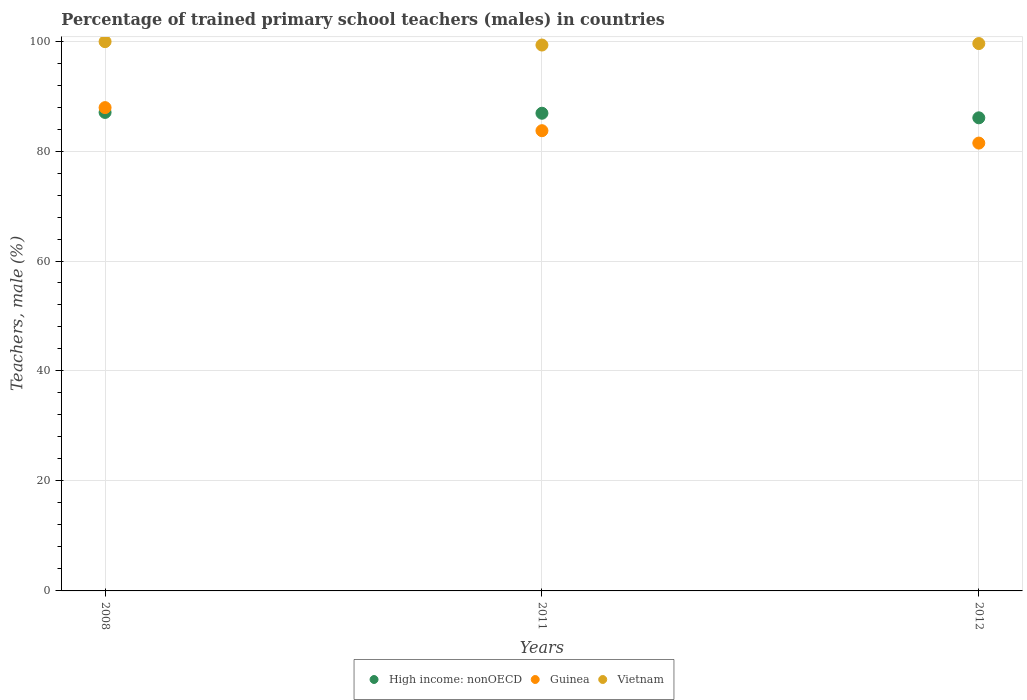What is the percentage of trained primary school teachers (males) in Vietnam in 2012?
Your answer should be very brief. 99.55. Across all years, what is the maximum percentage of trained primary school teachers (males) in Vietnam?
Provide a succinct answer. 99.89. Across all years, what is the minimum percentage of trained primary school teachers (males) in High income: nonOECD?
Make the answer very short. 86.04. In which year was the percentage of trained primary school teachers (males) in Vietnam maximum?
Your answer should be very brief. 2008. In which year was the percentage of trained primary school teachers (males) in Vietnam minimum?
Keep it short and to the point. 2011. What is the total percentage of trained primary school teachers (males) in Guinea in the graph?
Provide a succinct answer. 253.04. What is the difference between the percentage of trained primary school teachers (males) in High income: nonOECD in 2008 and that in 2012?
Keep it short and to the point. 0.98. What is the difference between the percentage of trained primary school teachers (males) in Vietnam in 2012 and the percentage of trained primary school teachers (males) in High income: nonOECD in 2008?
Your answer should be very brief. 12.53. What is the average percentage of trained primary school teachers (males) in High income: nonOECD per year?
Give a very brief answer. 86.64. In the year 2012, what is the difference between the percentage of trained primary school teachers (males) in Guinea and percentage of trained primary school teachers (males) in Vietnam?
Keep it short and to the point. -18.1. What is the ratio of the percentage of trained primary school teachers (males) in High income: nonOECD in 2008 to that in 2011?
Give a very brief answer. 1. Is the percentage of trained primary school teachers (males) in High income: nonOECD in 2008 less than that in 2011?
Give a very brief answer. No. What is the difference between the highest and the second highest percentage of trained primary school teachers (males) in Vietnam?
Your answer should be compact. 0.35. What is the difference between the highest and the lowest percentage of trained primary school teachers (males) in High income: nonOECD?
Provide a short and direct response. 0.98. Is the sum of the percentage of trained primary school teachers (males) in Vietnam in 2008 and 2012 greater than the maximum percentage of trained primary school teachers (males) in Guinea across all years?
Offer a terse response. Yes. Is the percentage of trained primary school teachers (males) in Vietnam strictly greater than the percentage of trained primary school teachers (males) in High income: nonOECD over the years?
Provide a succinct answer. Yes. Is the percentage of trained primary school teachers (males) in High income: nonOECD strictly less than the percentage of trained primary school teachers (males) in Vietnam over the years?
Your answer should be very brief. Yes. How many dotlines are there?
Make the answer very short. 3. How many years are there in the graph?
Provide a short and direct response. 3. Does the graph contain any zero values?
Offer a very short reply. No. How many legend labels are there?
Provide a short and direct response. 3. How are the legend labels stacked?
Make the answer very short. Horizontal. What is the title of the graph?
Give a very brief answer. Percentage of trained primary school teachers (males) in countries. Does "Cameroon" appear as one of the legend labels in the graph?
Your response must be concise. No. What is the label or title of the X-axis?
Make the answer very short. Years. What is the label or title of the Y-axis?
Your answer should be very brief. Teachers, male (%). What is the Teachers, male (%) in High income: nonOECD in 2008?
Offer a terse response. 87.02. What is the Teachers, male (%) of Guinea in 2008?
Your answer should be compact. 87.9. What is the Teachers, male (%) of Vietnam in 2008?
Make the answer very short. 99.89. What is the Teachers, male (%) in High income: nonOECD in 2011?
Make the answer very short. 86.87. What is the Teachers, male (%) in Guinea in 2011?
Your answer should be very brief. 83.7. What is the Teachers, male (%) of Vietnam in 2011?
Offer a very short reply. 99.28. What is the Teachers, male (%) of High income: nonOECD in 2012?
Give a very brief answer. 86.04. What is the Teachers, male (%) in Guinea in 2012?
Ensure brevity in your answer.  81.45. What is the Teachers, male (%) in Vietnam in 2012?
Your answer should be compact. 99.55. Across all years, what is the maximum Teachers, male (%) in High income: nonOECD?
Keep it short and to the point. 87.02. Across all years, what is the maximum Teachers, male (%) of Guinea?
Give a very brief answer. 87.9. Across all years, what is the maximum Teachers, male (%) of Vietnam?
Offer a very short reply. 99.89. Across all years, what is the minimum Teachers, male (%) in High income: nonOECD?
Keep it short and to the point. 86.04. Across all years, what is the minimum Teachers, male (%) of Guinea?
Ensure brevity in your answer.  81.45. Across all years, what is the minimum Teachers, male (%) in Vietnam?
Keep it short and to the point. 99.28. What is the total Teachers, male (%) in High income: nonOECD in the graph?
Offer a very short reply. 259.93. What is the total Teachers, male (%) in Guinea in the graph?
Give a very brief answer. 253.04. What is the total Teachers, male (%) in Vietnam in the graph?
Offer a very short reply. 298.72. What is the difference between the Teachers, male (%) in High income: nonOECD in 2008 and that in 2011?
Provide a short and direct response. 0.15. What is the difference between the Teachers, male (%) in Guinea in 2008 and that in 2011?
Offer a terse response. 4.2. What is the difference between the Teachers, male (%) in Vietnam in 2008 and that in 2011?
Keep it short and to the point. 0.62. What is the difference between the Teachers, male (%) in High income: nonOECD in 2008 and that in 2012?
Provide a succinct answer. 0.98. What is the difference between the Teachers, male (%) in Guinea in 2008 and that in 2012?
Provide a succinct answer. 6.45. What is the difference between the Teachers, male (%) of Vietnam in 2008 and that in 2012?
Provide a short and direct response. 0.35. What is the difference between the Teachers, male (%) of High income: nonOECD in 2011 and that in 2012?
Provide a succinct answer. 0.83. What is the difference between the Teachers, male (%) in Guinea in 2011 and that in 2012?
Give a very brief answer. 2.25. What is the difference between the Teachers, male (%) in Vietnam in 2011 and that in 2012?
Make the answer very short. -0.27. What is the difference between the Teachers, male (%) of High income: nonOECD in 2008 and the Teachers, male (%) of Guinea in 2011?
Offer a very short reply. 3.32. What is the difference between the Teachers, male (%) in High income: nonOECD in 2008 and the Teachers, male (%) in Vietnam in 2011?
Keep it short and to the point. -12.26. What is the difference between the Teachers, male (%) in Guinea in 2008 and the Teachers, male (%) in Vietnam in 2011?
Offer a very short reply. -11.38. What is the difference between the Teachers, male (%) of High income: nonOECD in 2008 and the Teachers, male (%) of Guinea in 2012?
Keep it short and to the point. 5.58. What is the difference between the Teachers, male (%) in High income: nonOECD in 2008 and the Teachers, male (%) in Vietnam in 2012?
Your answer should be compact. -12.53. What is the difference between the Teachers, male (%) in Guinea in 2008 and the Teachers, male (%) in Vietnam in 2012?
Your response must be concise. -11.65. What is the difference between the Teachers, male (%) in High income: nonOECD in 2011 and the Teachers, male (%) in Guinea in 2012?
Make the answer very short. 5.43. What is the difference between the Teachers, male (%) of High income: nonOECD in 2011 and the Teachers, male (%) of Vietnam in 2012?
Ensure brevity in your answer.  -12.67. What is the difference between the Teachers, male (%) in Guinea in 2011 and the Teachers, male (%) in Vietnam in 2012?
Give a very brief answer. -15.85. What is the average Teachers, male (%) in High income: nonOECD per year?
Offer a very short reply. 86.64. What is the average Teachers, male (%) of Guinea per year?
Provide a succinct answer. 84.35. What is the average Teachers, male (%) in Vietnam per year?
Provide a succinct answer. 99.57. In the year 2008, what is the difference between the Teachers, male (%) in High income: nonOECD and Teachers, male (%) in Guinea?
Your answer should be compact. -0.88. In the year 2008, what is the difference between the Teachers, male (%) in High income: nonOECD and Teachers, male (%) in Vietnam?
Keep it short and to the point. -12.87. In the year 2008, what is the difference between the Teachers, male (%) in Guinea and Teachers, male (%) in Vietnam?
Your response must be concise. -12. In the year 2011, what is the difference between the Teachers, male (%) of High income: nonOECD and Teachers, male (%) of Guinea?
Your response must be concise. 3.17. In the year 2011, what is the difference between the Teachers, male (%) of High income: nonOECD and Teachers, male (%) of Vietnam?
Offer a terse response. -12.4. In the year 2011, what is the difference between the Teachers, male (%) in Guinea and Teachers, male (%) in Vietnam?
Give a very brief answer. -15.58. In the year 2012, what is the difference between the Teachers, male (%) in High income: nonOECD and Teachers, male (%) in Guinea?
Offer a very short reply. 4.59. In the year 2012, what is the difference between the Teachers, male (%) in High income: nonOECD and Teachers, male (%) in Vietnam?
Give a very brief answer. -13.51. In the year 2012, what is the difference between the Teachers, male (%) of Guinea and Teachers, male (%) of Vietnam?
Provide a short and direct response. -18.1. What is the ratio of the Teachers, male (%) in Guinea in 2008 to that in 2011?
Keep it short and to the point. 1.05. What is the ratio of the Teachers, male (%) in High income: nonOECD in 2008 to that in 2012?
Your answer should be very brief. 1.01. What is the ratio of the Teachers, male (%) in Guinea in 2008 to that in 2012?
Your response must be concise. 1.08. What is the ratio of the Teachers, male (%) in Vietnam in 2008 to that in 2012?
Your response must be concise. 1. What is the ratio of the Teachers, male (%) in High income: nonOECD in 2011 to that in 2012?
Your response must be concise. 1.01. What is the ratio of the Teachers, male (%) in Guinea in 2011 to that in 2012?
Your answer should be very brief. 1.03. What is the ratio of the Teachers, male (%) of Vietnam in 2011 to that in 2012?
Your answer should be very brief. 1. What is the difference between the highest and the second highest Teachers, male (%) in High income: nonOECD?
Provide a succinct answer. 0.15. What is the difference between the highest and the second highest Teachers, male (%) in Guinea?
Make the answer very short. 4.2. What is the difference between the highest and the second highest Teachers, male (%) in Vietnam?
Offer a very short reply. 0.35. What is the difference between the highest and the lowest Teachers, male (%) of High income: nonOECD?
Keep it short and to the point. 0.98. What is the difference between the highest and the lowest Teachers, male (%) of Guinea?
Your response must be concise. 6.45. What is the difference between the highest and the lowest Teachers, male (%) of Vietnam?
Ensure brevity in your answer.  0.62. 